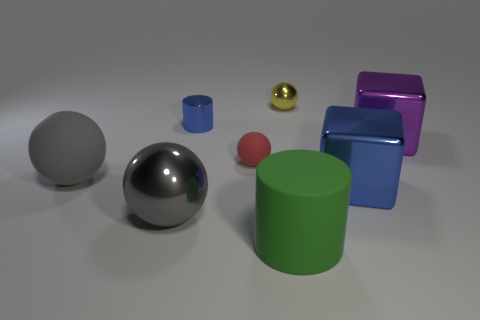Subtract all tiny yellow balls. How many balls are left? 3 Subtract all cyan cylinders. How many gray spheres are left? 2 Add 2 blue metal blocks. How many objects exist? 10 Subtract all yellow spheres. How many spheres are left? 3 Subtract 1 cylinders. How many cylinders are left? 1 Subtract 0 gray cubes. How many objects are left? 8 Subtract all cylinders. How many objects are left? 6 Subtract all red cylinders. Subtract all purple cubes. How many cylinders are left? 2 Subtract all metallic objects. Subtract all tiny cylinders. How many objects are left? 2 Add 1 large purple shiny things. How many large purple shiny things are left? 2 